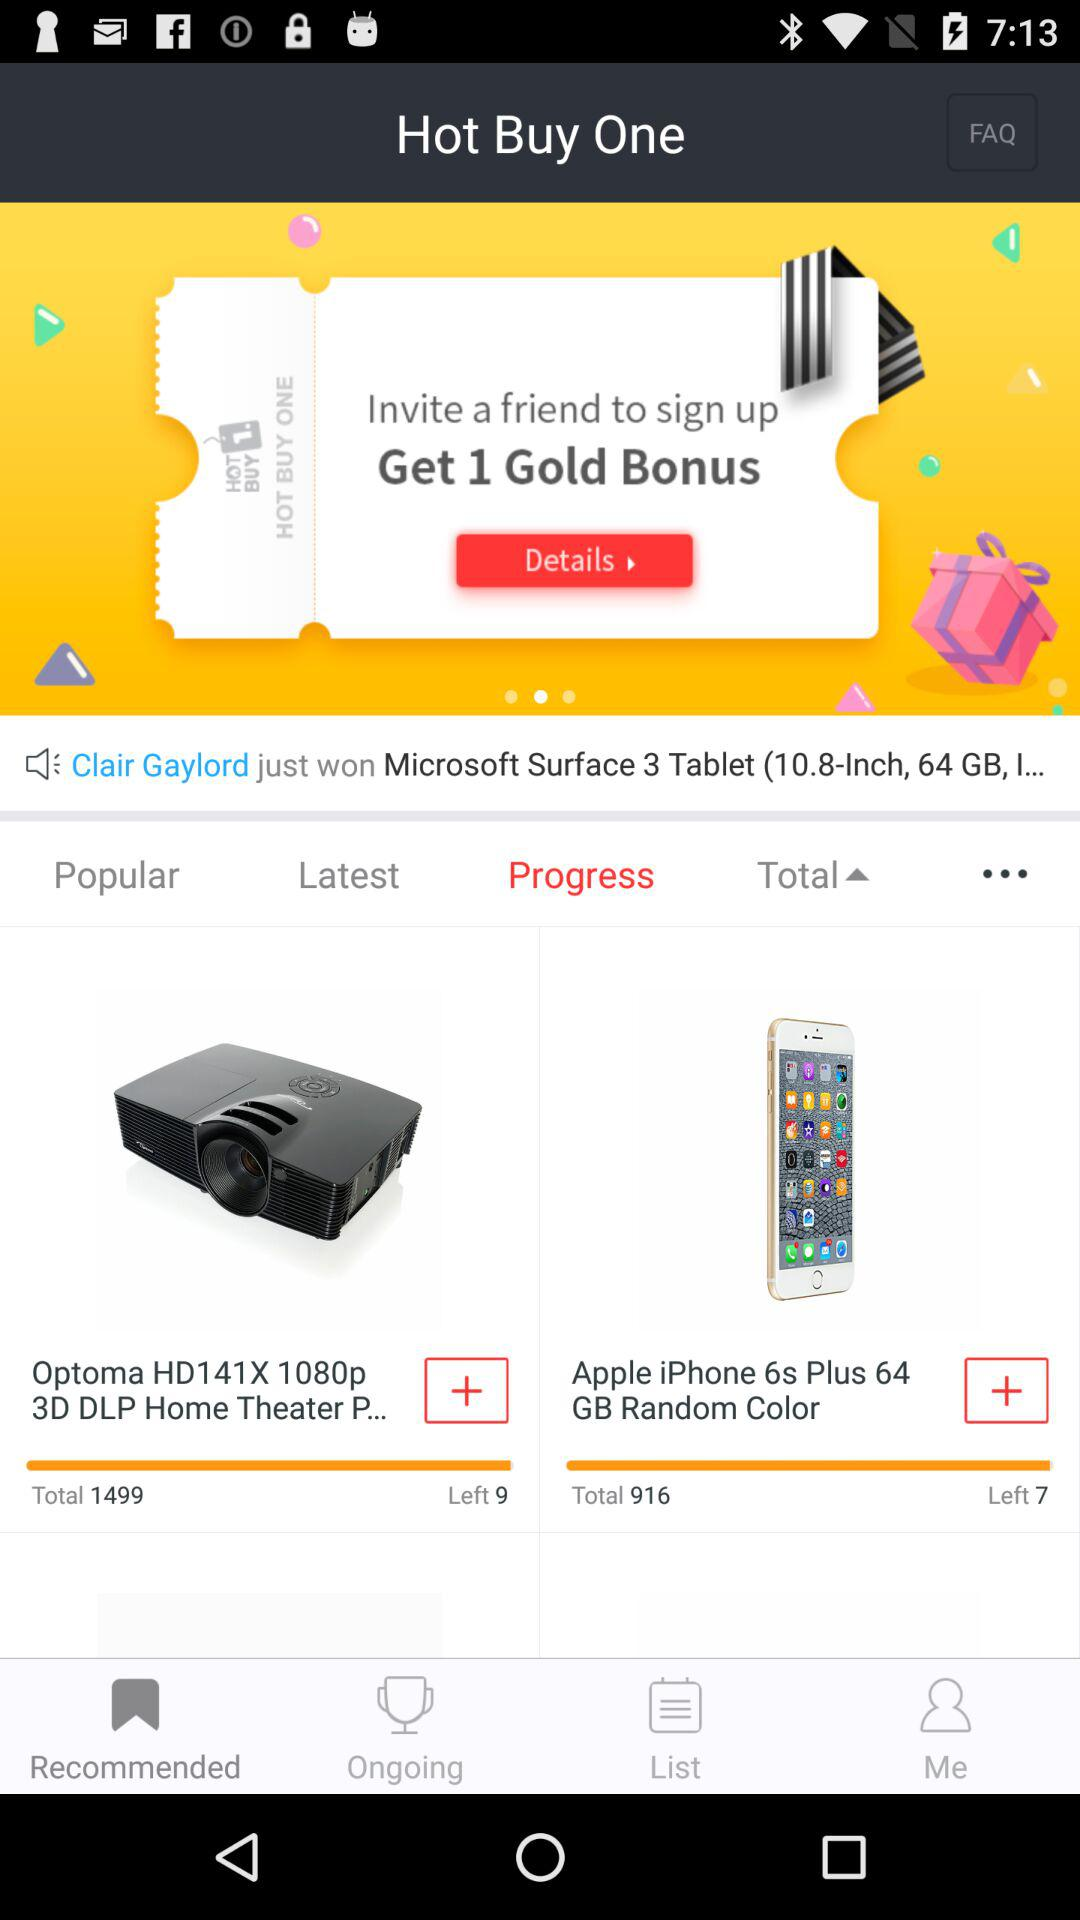Which option is selected? The selected options are "Recommended" and "Progress". 